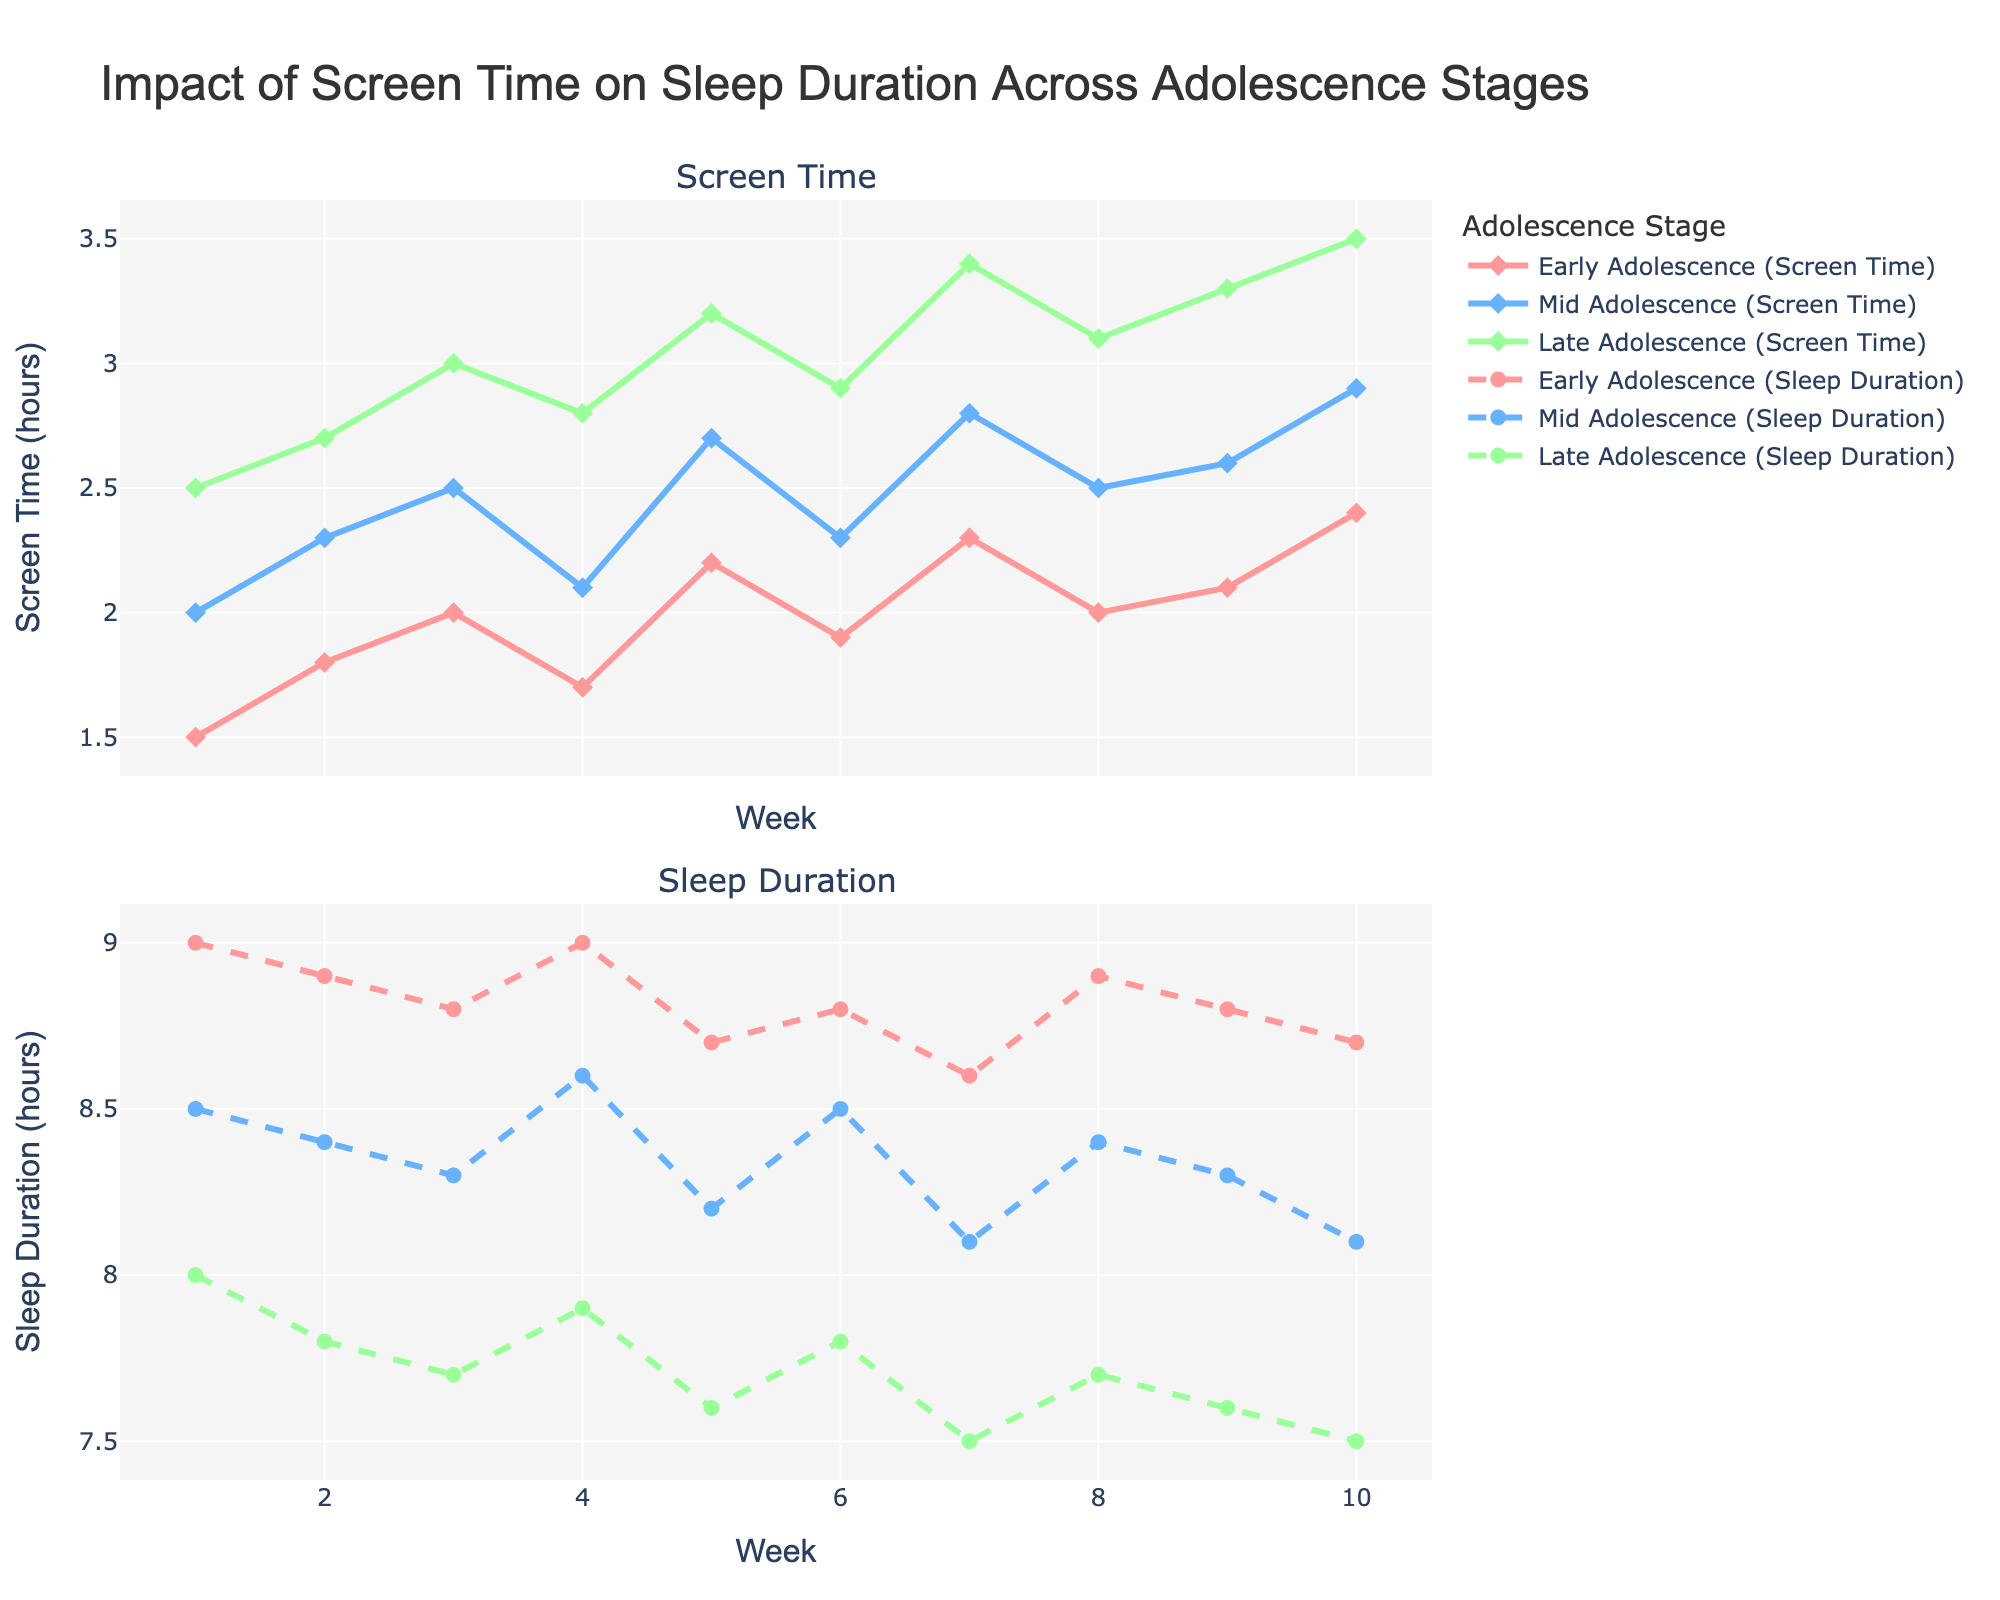What is the title of the plot? The title is usually displayed at the top of the plot. It summarizes the main topic or data being visualized. The provided code specifies that the title for this plot is "Impact of Screen Time on Sleep Duration Across Adolescence Stages".
Answer: Impact of Screen Time on Sleep Duration Across Adolescence Stages What is the color used for "Early Adolescence" screen time? The color used for "Early Adolescence" screen time can be identified by looking at the legend or the colored line and markers associated with the "Early Adolescence" label. The code indicates that the color is a shade of red.
Answer: Red Between Week 1 and Week 10, which stage of adolescence shows the highest amount of screen time? By examining the lines representing screen time across different stages, we can compare the heights of the lines. The higher the line, the more screen time. Observing the trends, the "Late Adolescence" group consistently has the highest screen time.
Answer: Late Adolescence How does sleep duration change in the Mid Adolescence group from Week 1 to Week 10? By tracing the line corresponding to "Mid Adolescence" sleep duration from Week 1 to Week 10, we observe the values at each week. We see a general downward trend, starting from 8.5 hours in Week 1 to 8.1 hours in Week 10.
Answer: It decreases from 8.5 to 8.1 hours Which week shows the greatest disparity in screen time between "Early Adolescence" and "Late Adolescence"? Identify the week where the difference between screen time for "Early Adolescence" and "Late Adolescence" is maximal. Subtract the values for these groups for each week and find the maximum difference. Week 9 shows a large difference, but Week 10 has the greatest disparity (2.4 vs 3.5).
Answer: Week 10 On average, how many hours do "Late Adolescence" adolescents sleep per week over the 10 weeks? Calculate the mean sleep duration for "Late Adolescence" by adding up the sleep durations for all weeks and dividing by the number of weeks. Sum of sleep hours (8.0 + 7.8 + 7.7 + 7.9 + 7.6 + 7.8 + 7.5 + 7.7 + 7.6 + 7.5) is 77.1 hours. The average is 77.1 / 10 = 7.71 hours.
Answer: 7.71 hours Which stage of adolescence seems to have the most stable sleep duration over the 10 weeks? The stability of sleep duration can be observed by how flat or consistent the line is across the weeks. Compare the sleep duration lines of all stages. "Early Adolescence" appears most stable, fluctuating slightly around 8.8-9.0 hours.
Answer: Early Adolescence Is there any week where all stages have equal sleep durations? Look for a week where the sleep duration values for "Early Adolescence", "Mid Adolescence", and "Late Adolescence" are the same. Upon examining the plot, no week shows equal sleep durations for all groups.
Answer: No What is the overall trend in screen time for "Mid Adolescence" from Week 1 to Week 10? By observing the line representing "Mid Adolescence" screen time from Week 1 to Week 10, we identify an increasing trend, starting at 2.0 hours and ending at 2.9 hours, with some fluctuations.
Answer: Increasing Between Week 1 and Week 10, which group shows the smallest change in sleep duration? Calculate the difference in sleep duration from Week 1 to Week 10 for each group. "Early Adolescence" sleeps 9 hours in Week 1 and 8.7 in Week 10, a change of 0.3 hours; "Mid Adolescence" changes by 0.4 hours; "Late Adolescence" changes by 0.5 hours. Thus, "Early Adolescence" shows the smallest change.
Answer: Early Adolescence 